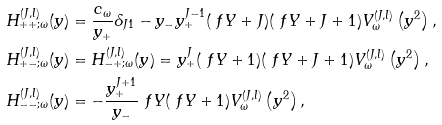<formula> <loc_0><loc_0><loc_500><loc_500>H ^ { ( J , l ) } _ { + + ; \omega } ( y ) & = \frac { c _ { \omega } } { y _ { + } } \delta _ { J 1 } - y _ { - } y _ { + } ^ { J - 1 } ( \ f Y + J ) ( \ f Y + J + 1 ) V ^ { ( J , l ) } _ { \omega } \left ( y ^ { 2 } \right ) , \\ H ^ { ( J , l ) } _ { + - ; \omega } ( y ) & = H ^ { ( J , l ) } _ { - + ; \omega } ( y ) = y _ { + } ^ { J } ( \ f Y + 1 ) ( \ f Y + J + 1 ) V ^ { ( J , l ) } _ { \omega } \left ( y ^ { 2 } \right ) , \\ H ^ { ( J , l ) } _ { - - ; \omega } ( y ) & = - \frac { y _ { + } ^ { J + 1 } } { y _ { - } } \ f Y ( \ f Y + 1 ) V ^ { ( J , l ) } _ { \omega } \left ( y ^ { 2 } \right ) ,</formula> 